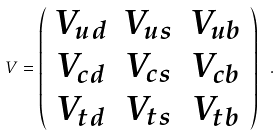Convert formula to latex. <formula><loc_0><loc_0><loc_500><loc_500>V = \left ( \begin{array} { c c c } V _ { u d } & V _ { u s } & V _ { u b } \\ V _ { c d } & V _ { c s } & V _ { c b } \\ V _ { t d } & V _ { t s } & V _ { t b } \end{array} \right ) \ .</formula> 